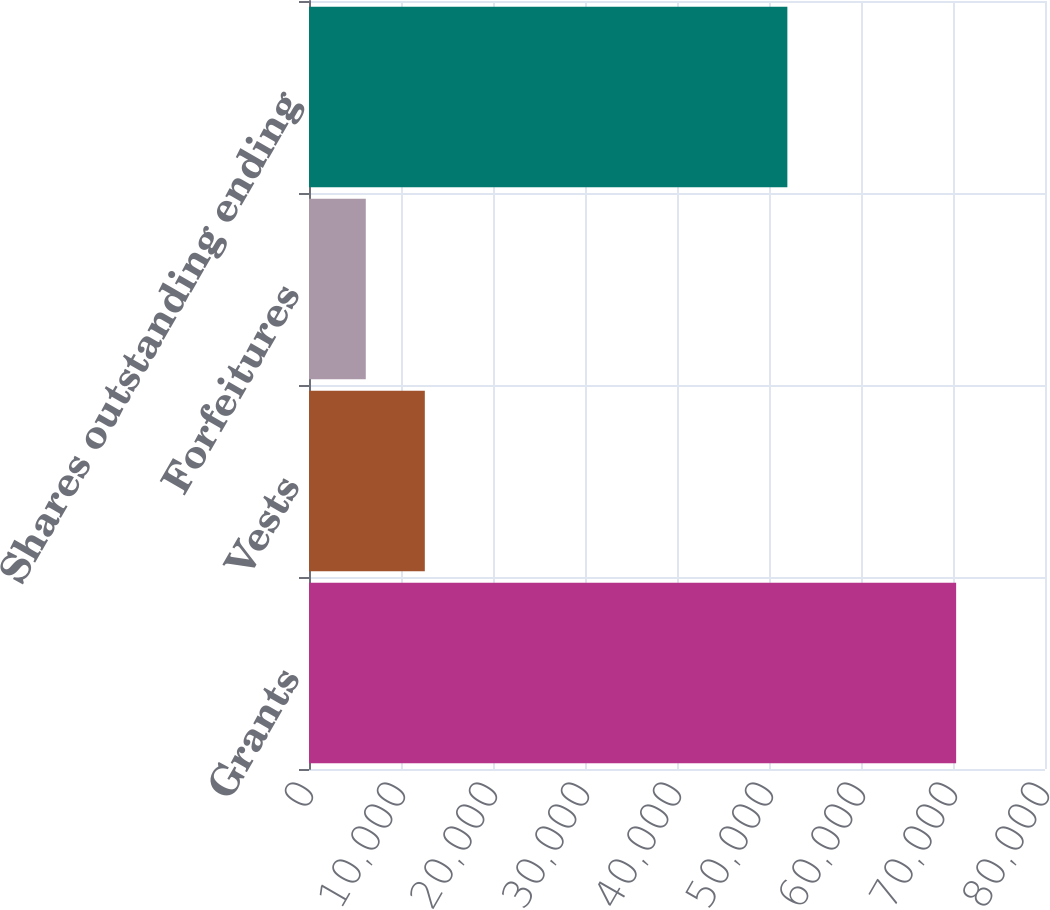Convert chart to OTSL. <chart><loc_0><loc_0><loc_500><loc_500><bar_chart><fcel>Grants<fcel>Vests<fcel>Forfeitures<fcel>Shares outstanding ending<nl><fcel>70341<fcel>12588.9<fcel>6172<fcel>51996<nl></chart> 